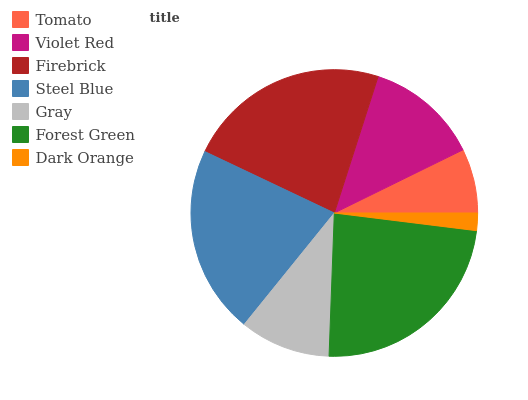Is Dark Orange the minimum?
Answer yes or no. Yes. Is Forest Green the maximum?
Answer yes or no. Yes. Is Violet Red the minimum?
Answer yes or no. No. Is Violet Red the maximum?
Answer yes or no. No. Is Violet Red greater than Tomato?
Answer yes or no. Yes. Is Tomato less than Violet Red?
Answer yes or no. Yes. Is Tomato greater than Violet Red?
Answer yes or no. No. Is Violet Red less than Tomato?
Answer yes or no. No. Is Violet Red the high median?
Answer yes or no. Yes. Is Violet Red the low median?
Answer yes or no. Yes. Is Tomato the high median?
Answer yes or no. No. Is Forest Green the low median?
Answer yes or no. No. 